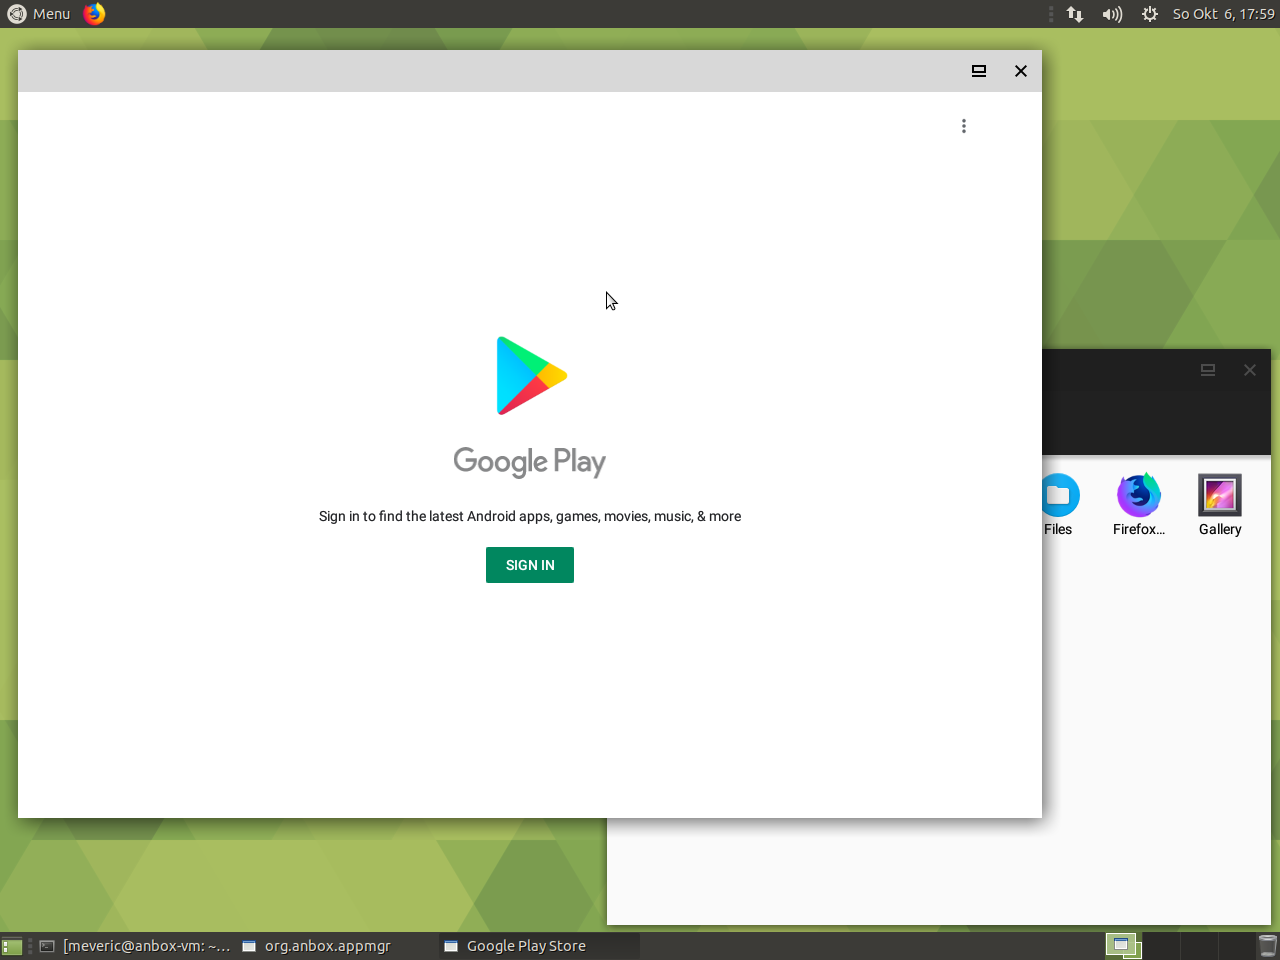What does the presence of a Google Play Store suggest about the capabilities of this device? The presence of the Google Play Store within this desktop interface suggests that the device has the capability to install and run Android applications. This extends the functionality of the device beyond what is typically expected from a standard desktop OS, by providing access to a vast library of apps designed for mobile platforms. It implies a versatile computing environment where the user can benefit from both desktop and mobile app ecosystems. 